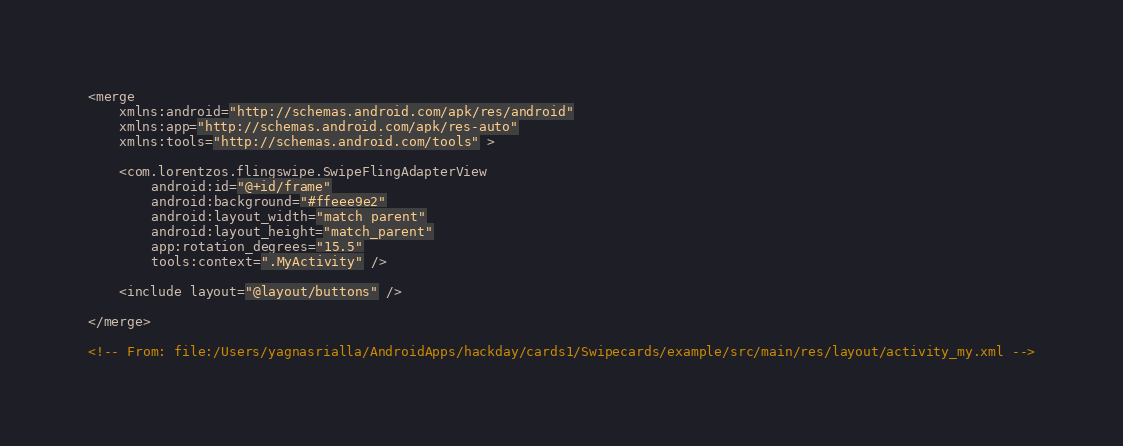Convert code to text. <code><loc_0><loc_0><loc_500><loc_500><_XML_><merge
    xmlns:android="http://schemas.android.com/apk/res/android"
    xmlns:app="http://schemas.android.com/apk/res-auto"
    xmlns:tools="http://schemas.android.com/tools" >

    <com.lorentzos.flingswipe.SwipeFlingAdapterView
        android:id="@+id/frame"
        android:background="#ffeee9e2"
        android:layout_width="match_parent"
        android:layout_height="match_parent"
        app:rotation_degrees="15.5"
        tools:context=".MyActivity" />

    <include layout="@layout/buttons" />

</merge>

<!-- From: file:/Users/yagnasrialla/AndroidApps/hackday/cards1/Swipecards/example/src/main/res/layout/activity_my.xml --></code> 